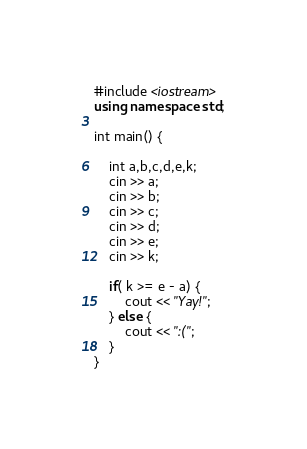<code> <loc_0><loc_0><loc_500><loc_500><_C++_>#include <iostream>
using namespace std;

int main() {

    int a,b,c,d,e,k;
    cin >> a;
    cin >> b;
    cin >> c;
    cin >> d;
    cin >> e;
    cin >> k;

    if( k >= e - a) {
        cout << "Yay!";
    } else {
        cout << ":(";
    }
}</code> 